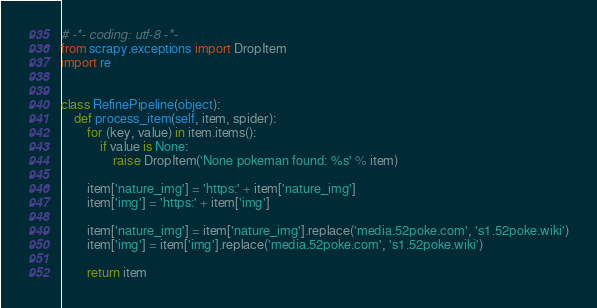<code> <loc_0><loc_0><loc_500><loc_500><_Python_># -*- coding: utf-8 -*-
from scrapy.exceptions import DropItem
import re


class RefinePipeline(object):
    def process_item(self, item, spider):
        for (key, value) in item.items():
            if value is None:
                raise DropItem('None pokeman found: %s' % item)

        item['nature_img'] = 'https:' + item['nature_img']
        item['img'] = 'https:' + item['img']

        item['nature_img'] = item['nature_img'].replace('media.52poke.com', 's1.52poke.wiki')
        item['img'] = item['img'].replace('media.52poke.com', 's1.52poke.wiki')

        return item
</code> 